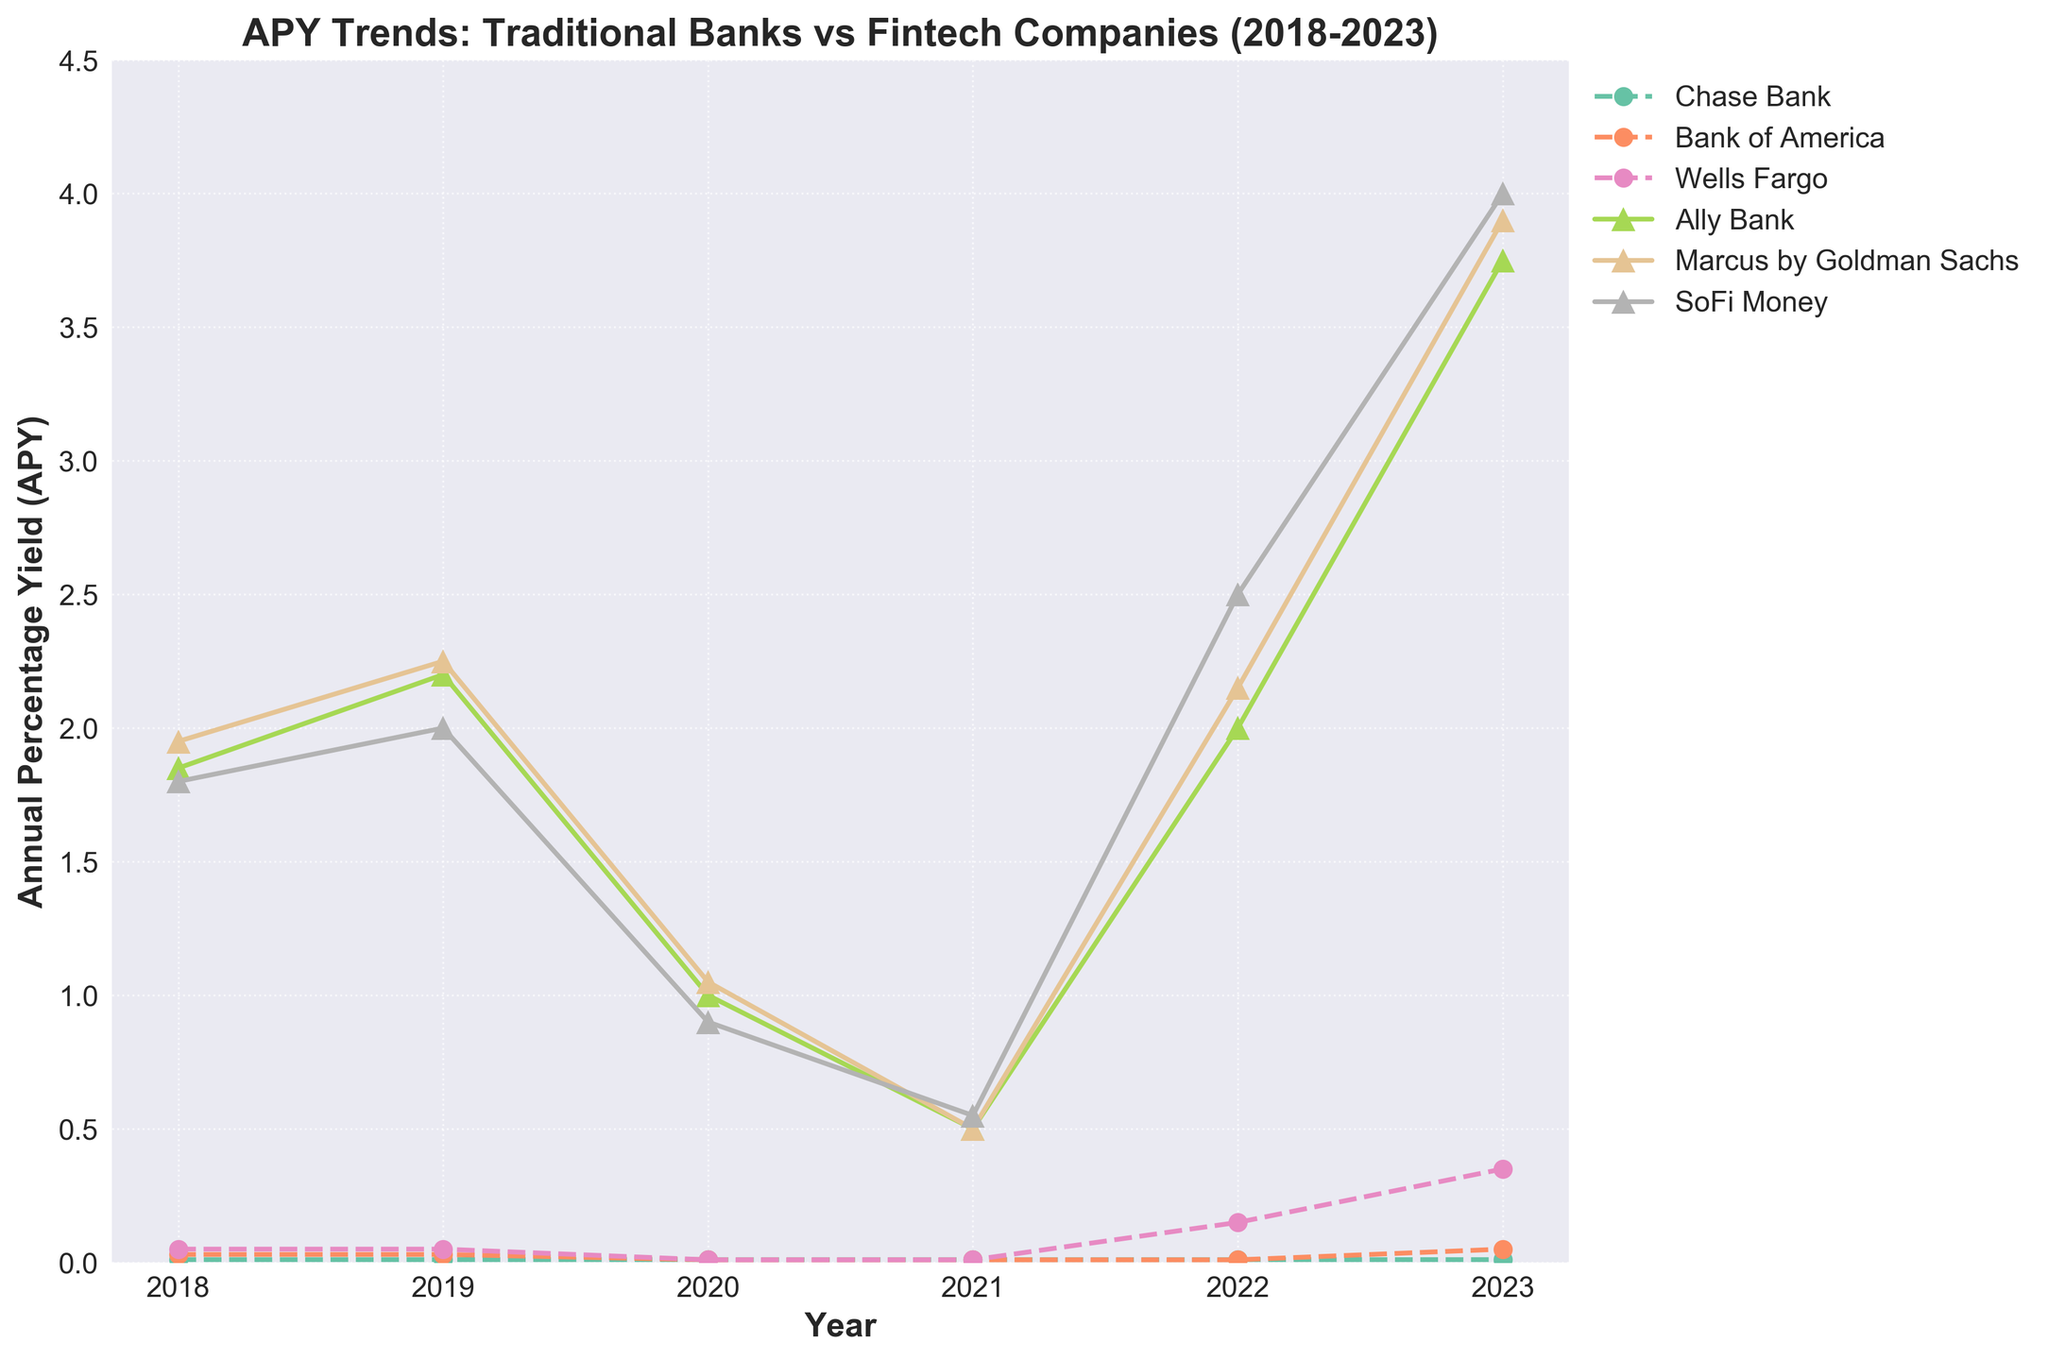What is the APY trend for Chase Bank from 2018 to 2023? Chase Bank's APY remains constant at 0.01% from 2018 to 2021, then increases slightly to 0.15% in 2022 and further to 0.35% in 2023.
Answer: 0.01%, 0.01%, 0.01%, 0.01%, 0.15%, 0.35% Which company offers the highest APY in 2023? In 2023, SoFi Money offers the highest APY at 4.00%.
Answer: SoFi Money How does the APY for Ally Bank change from 2018 to 2023? Ally Bank's APY starts at 1.85% in 2018, rises to 2.20% in 2019, drops to 1.00% in 2020, further decreases to 0.50% in 2021, increases to 2.00% in 2022, and peaks at 3.75% in 2023.
Answer: 1.85%, 2.20%, 1.00%, 0.50%, 2.00%, 3.75% Compare the APY of Bank of America and Marcus by Goldman Sachs in 2022. In 2022, Bank of America's APY is 0.01%, while Marcus by Goldman Sachs offers 2.15%.
Answer: 0.01%, 2.15% Which traditional bank shows the greatest increase in APY from 2022 to 2023? Wells Fargo increases its APY from 0.15% in 2022 to 0.35% in 2023.
Answer: Wells Fargo What is the average APY of SoFi Money from 2018 to 2023? The sum of SoFi Money's APYs from 2018 to 2023 is (1.80 + 2.00 + 0.90 + 0.55 + 2.50 + 4.00) = 11.75%. The average is 11.75 / 6 = 1.96%.
Answer: 1.96% Which fintech company had the most consistent APY from 2018 to 2023? Marcus by Goldman Sachs shows the most consistent trend with moderate variations: 1.95%, 2.25%, 1.05%, 0.50%, 2.15%, 3.90%.
Answer: Marcus by Goldman Sachs 